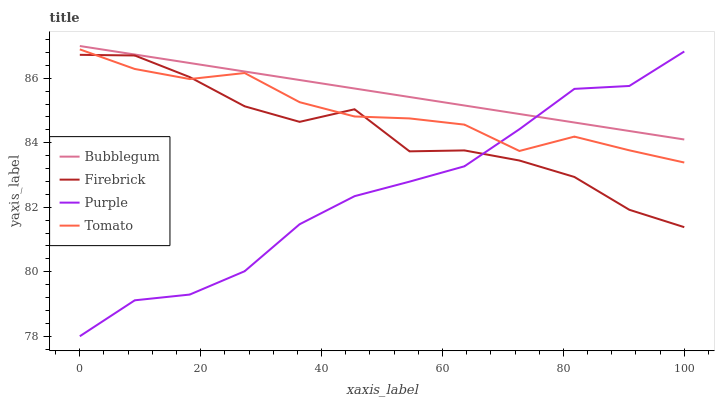Does Purple have the minimum area under the curve?
Answer yes or no. Yes. Does Bubblegum have the maximum area under the curve?
Answer yes or no. Yes. Does Tomato have the minimum area under the curve?
Answer yes or no. No. Does Tomato have the maximum area under the curve?
Answer yes or no. No. Is Bubblegum the smoothest?
Answer yes or no. Yes. Is Firebrick the roughest?
Answer yes or no. Yes. Is Tomato the smoothest?
Answer yes or no. No. Is Tomato the roughest?
Answer yes or no. No. Does Purple have the lowest value?
Answer yes or no. Yes. Does Tomato have the lowest value?
Answer yes or no. No. Does Bubblegum have the highest value?
Answer yes or no. Yes. Does Tomato have the highest value?
Answer yes or no. No. Is Firebrick less than Bubblegum?
Answer yes or no. Yes. Is Bubblegum greater than Firebrick?
Answer yes or no. Yes. Does Purple intersect Firebrick?
Answer yes or no. Yes. Is Purple less than Firebrick?
Answer yes or no. No. Is Purple greater than Firebrick?
Answer yes or no. No. Does Firebrick intersect Bubblegum?
Answer yes or no. No. 